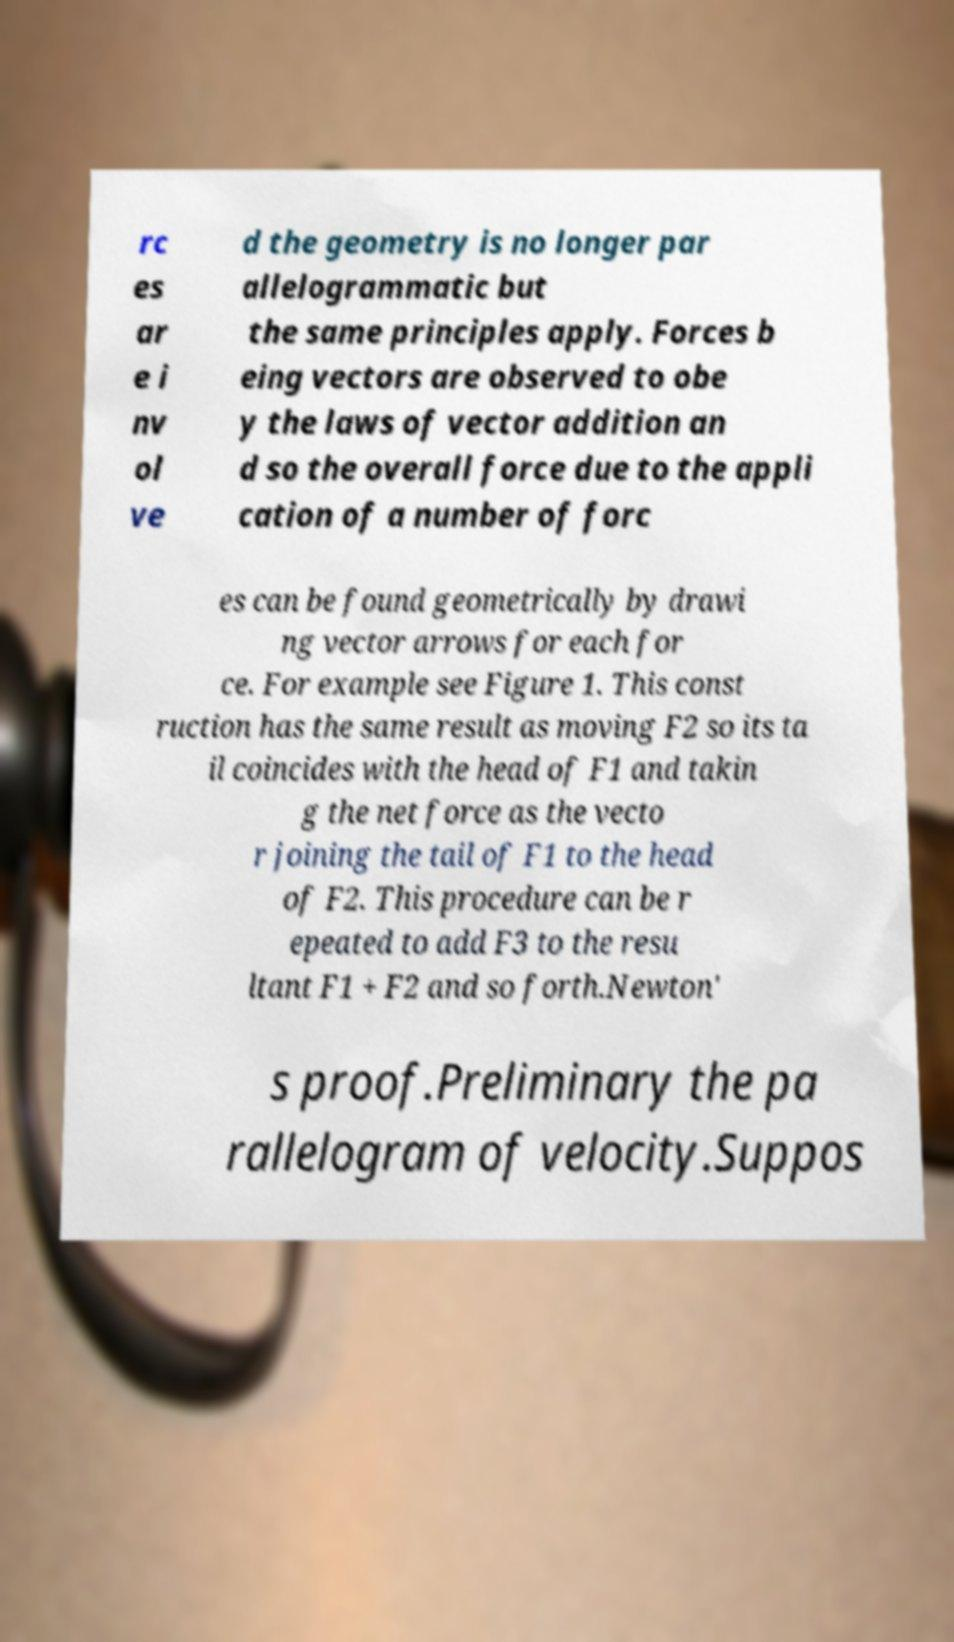For documentation purposes, I need the text within this image transcribed. Could you provide that? rc es ar e i nv ol ve d the geometry is no longer par allelogrammatic but the same principles apply. Forces b eing vectors are observed to obe y the laws of vector addition an d so the overall force due to the appli cation of a number of forc es can be found geometrically by drawi ng vector arrows for each for ce. For example see Figure 1. This const ruction has the same result as moving F2 so its ta il coincides with the head of F1 and takin g the net force as the vecto r joining the tail of F1 to the head of F2. This procedure can be r epeated to add F3 to the resu ltant F1 + F2 and so forth.Newton' s proof.Preliminary the pa rallelogram of velocity.Suppos 